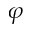Convert formula to latex. <formula><loc_0><loc_0><loc_500><loc_500>\varphi</formula> 